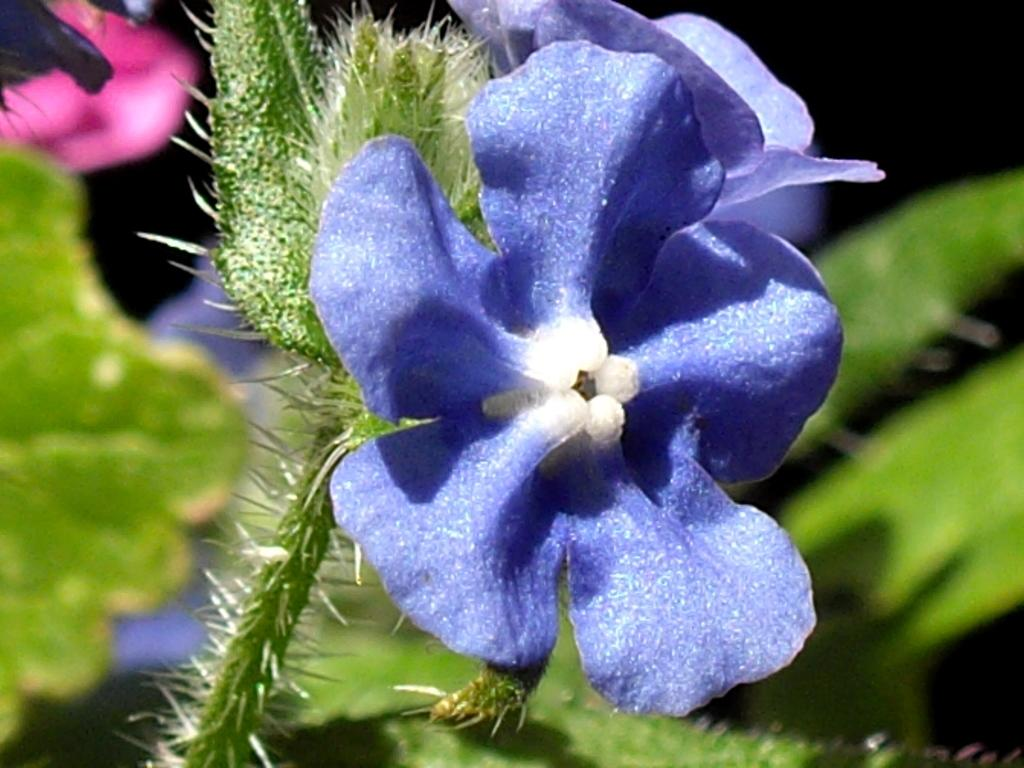What is present in the image? There is a plant in the image. Can you describe the plant's flower? The plant has a violet-colored flower. What songs does your aunt sing while watering the plant in the image? There is no mention of an aunt or songs in the image, as it only features a plant with a violet-colored flower. 